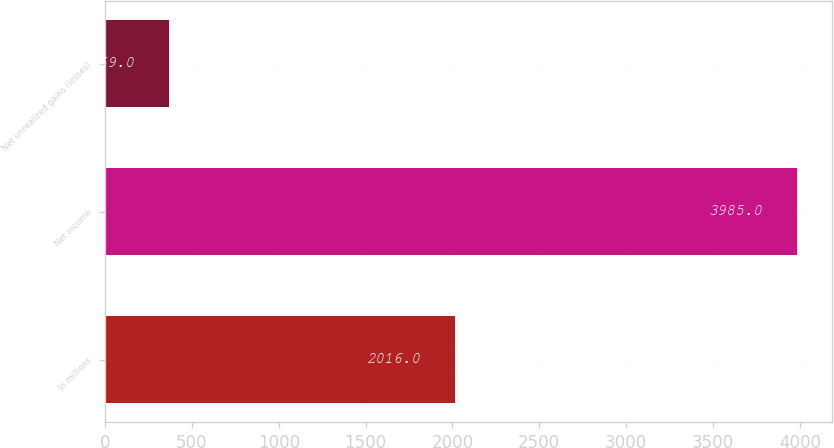Convert chart. <chart><loc_0><loc_0><loc_500><loc_500><bar_chart><fcel>In millions<fcel>Net income<fcel>Net unrealized gains (losses)<nl><fcel>2016<fcel>3985<fcel>369<nl></chart> 